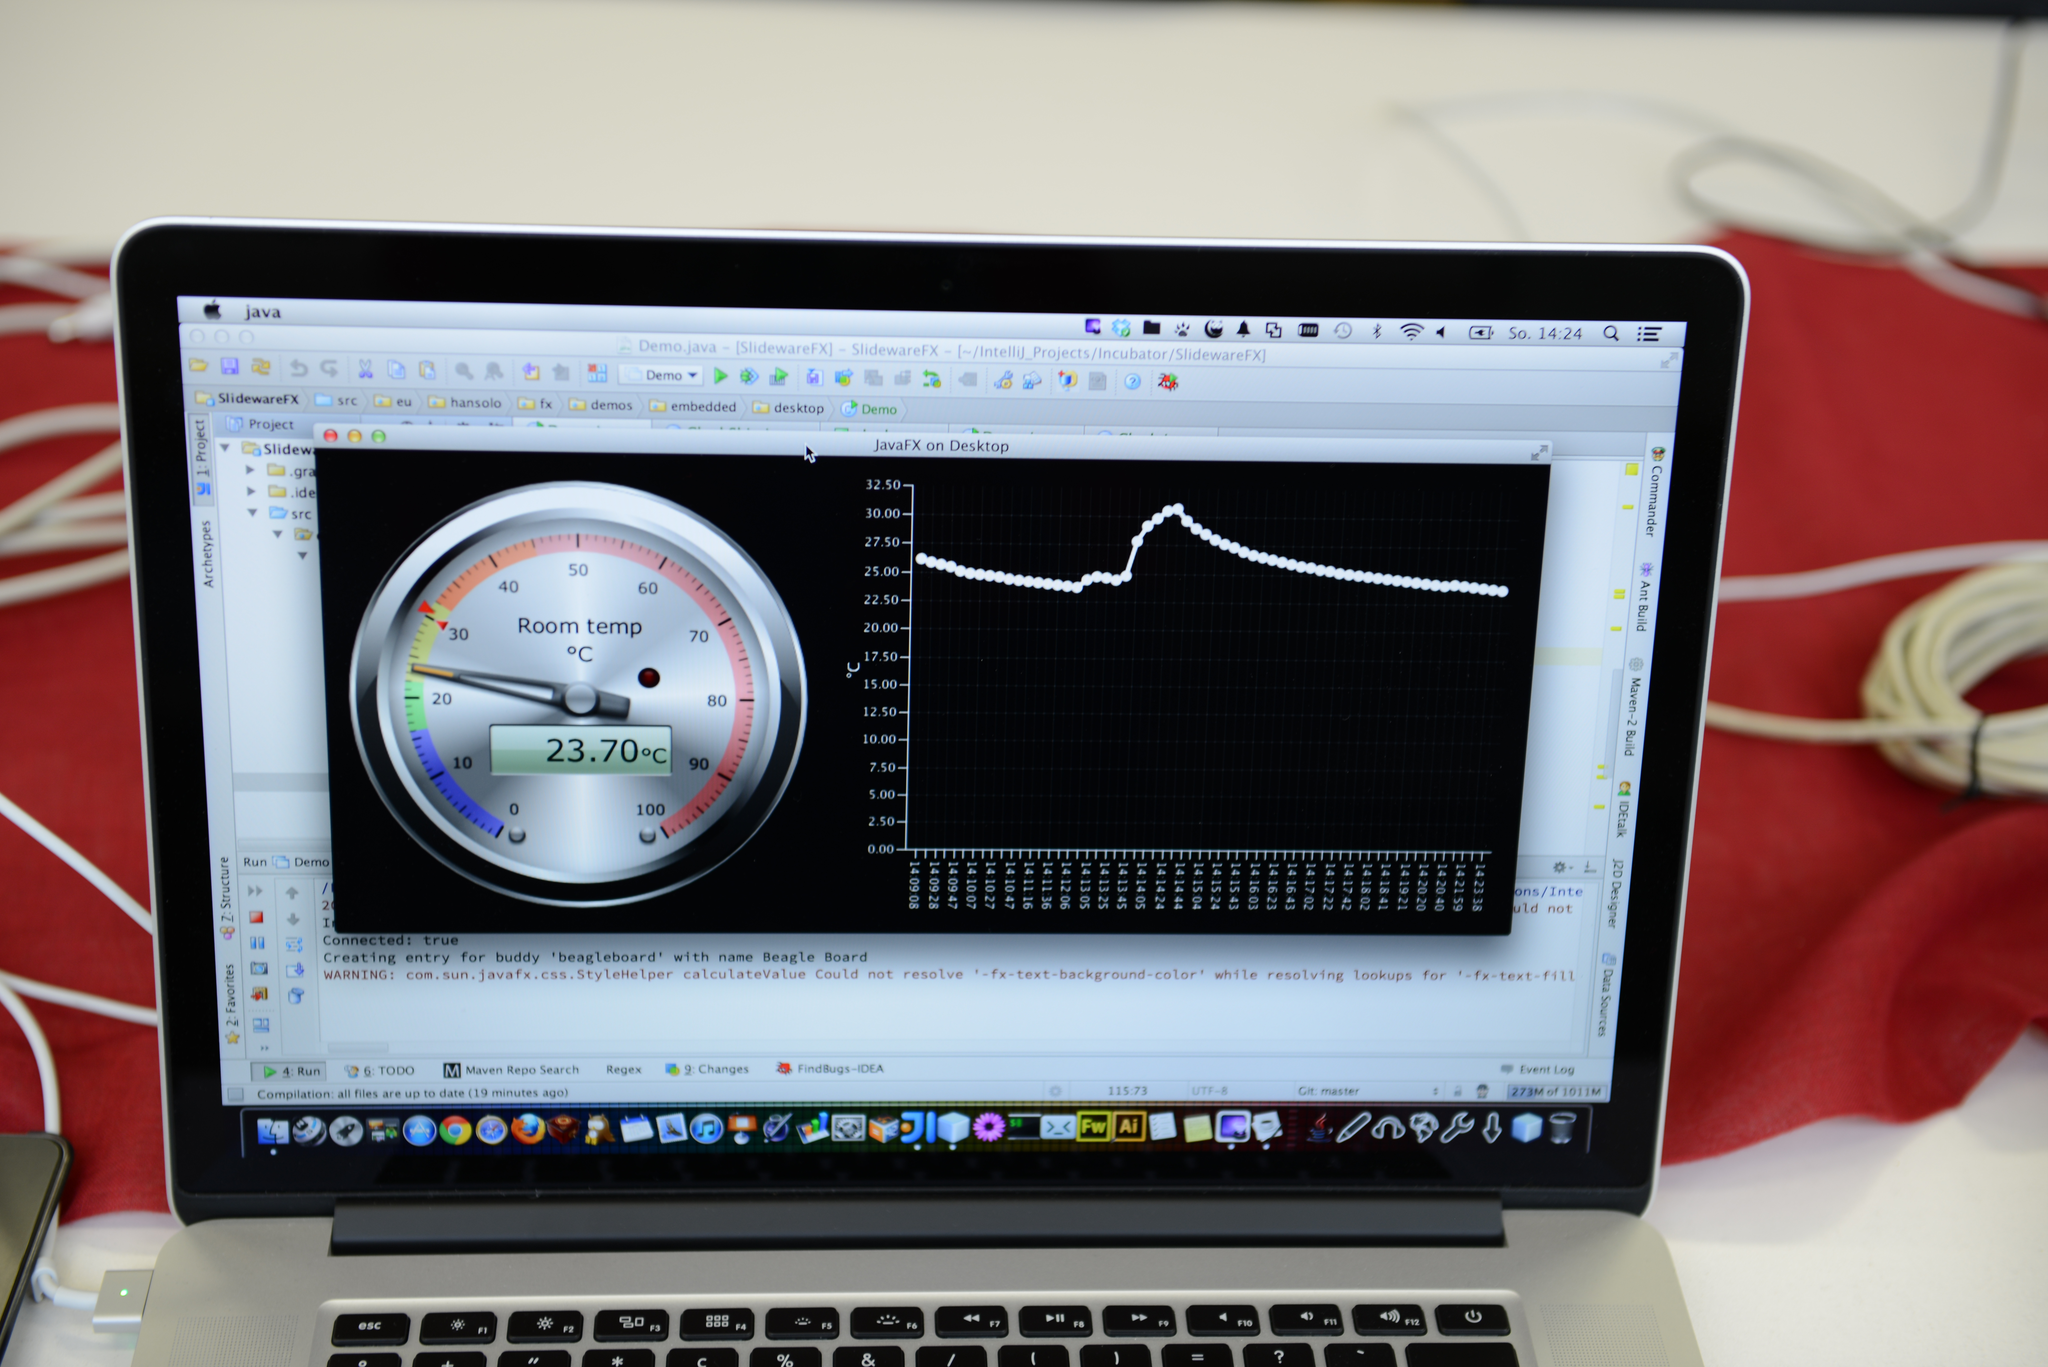Describe this image in one or two sentences. In this image, there is a laptop showing statistics of a temperature on the screen. There is a cable on the right side of the image. 